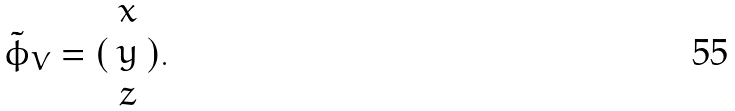Convert formula to latex. <formula><loc_0><loc_0><loc_500><loc_500>\tilde { \phi } _ { V } = ( \begin{array} { c } x \\ y \\ z \end{array} ) .</formula> 